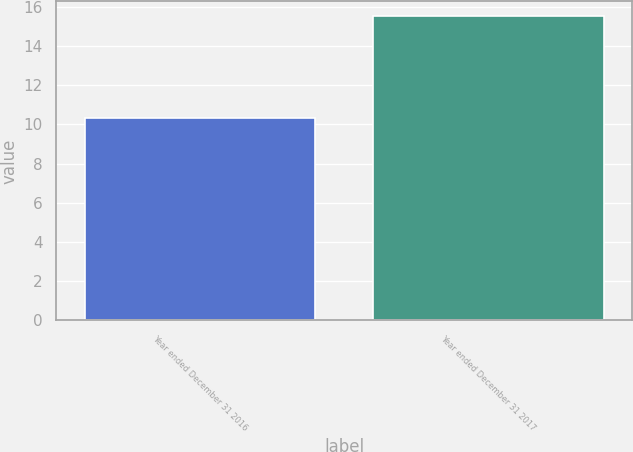Convert chart to OTSL. <chart><loc_0><loc_0><loc_500><loc_500><bar_chart><fcel>Year ended December 31 2016<fcel>Year ended December 31 2017<nl><fcel>10.3<fcel>15.5<nl></chart> 